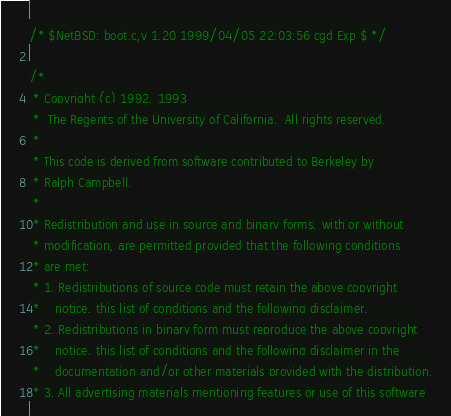<code> <loc_0><loc_0><loc_500><loc_500><_C_>/* $NetBSD: boot.c,v 1.20 1999/04/05 22:03:56 cgd Exp $ */

/*
 * Copyright (c) 1992, 1993
 *	The Regents of the University of California.  All rights reserved.
 *
 * This code is derived from software contributed to Berkeley by
 * Ralph Campbell.
 *
 * Redistribution and use in source and binary forms, with or without
 * modification, are permitted provided that the following conditions
 * are met:
 * 1. Redistributions of source code must retain the above copyright
 *    notice, this list of conditions and the following disclaimer.
 * 2. Redistributions in binary form must reproduce the above copyright
 *    notice, this list of conditions and the following disclaimer in the
 *    documentation and/or other materials provided with the distribution.
 * 3. All advertising materials mentioning features or use of this software</code> 